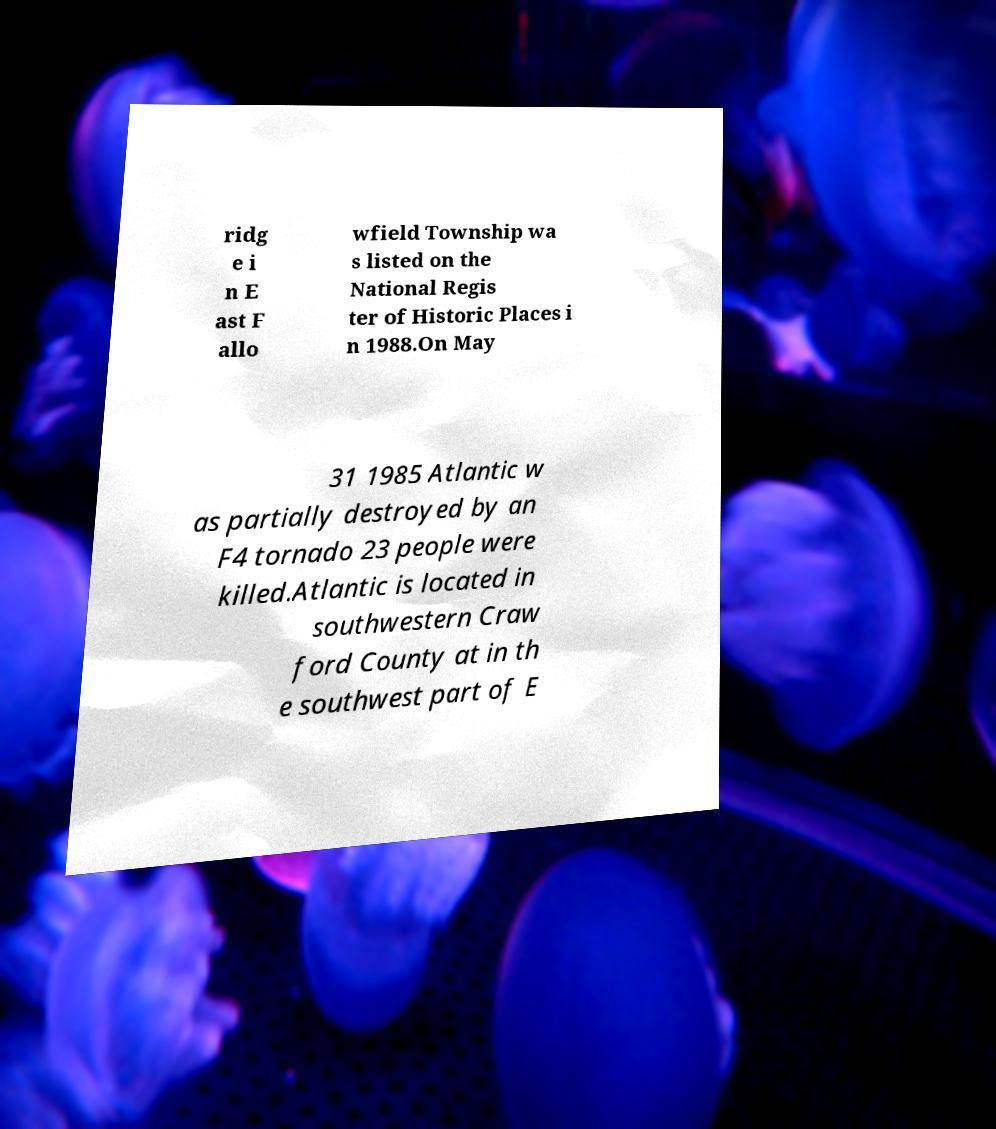Please identify and transcribe the text found in this image. ridg e i n E ast F allo wfield Township wa s listed on the National Regis ter of Historic Places i n 1988.On May 31 1985 Atlantic w as partially destroyed by an F4 tornado 23 people were killed.Atlantic is located in southwestern Craw ford County at in th e southwest part of E 